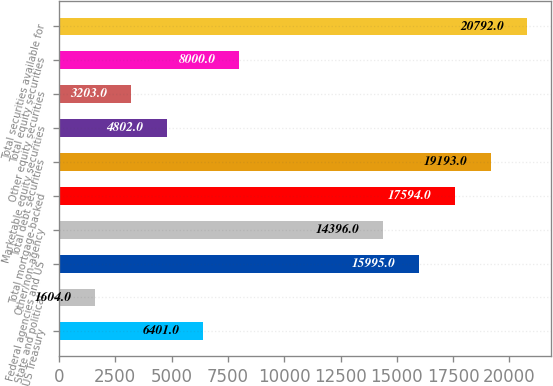Convert chart. <chart><loc_0><loc_0><loc_500><loc_500><bar_chart><fcel>US Treasury<fcel>State and political<fcel>Federal agencies and US<fcel>Other/non-agency<fcel>Total mortgage-backed<fcel>Total debt securities<fcel>Marketable equity securities<fcel>Other equity securities<fcel>Total equity securities<fcel>Total securities available for<nl><fcel>6401<fcel>1604<fcel>15995<fcel>14396<fcel>17594<fcel>19193<fcel>4802<fcel>3203<fcel>8000<fcel>20792<nl></chart> 